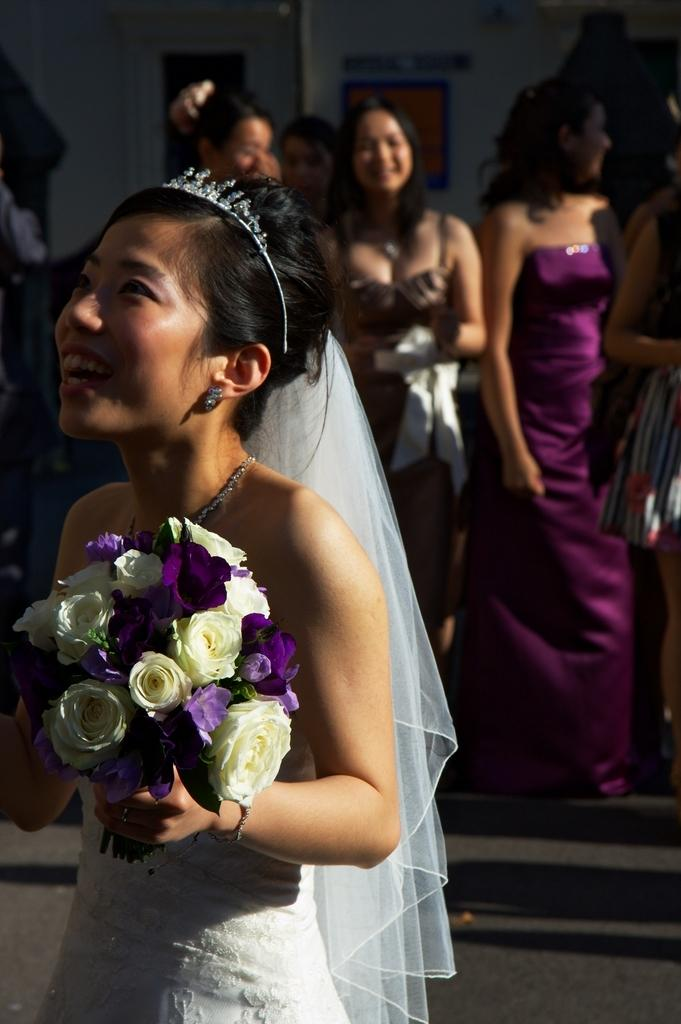What is happening in the image? There are people standing in the image. Can you describe the woman in the image? There is a woman holding flowers in her hand. What can be seen in the background of the image? There appears to be a building in the background of the image. What type of carriage is being pulled by the horses in the image? There are no horses or carriages present in the image. What kind of shoes is the woman wearing in the image? The image does not show the woman's shoes, so it cannot be determined from the image. 